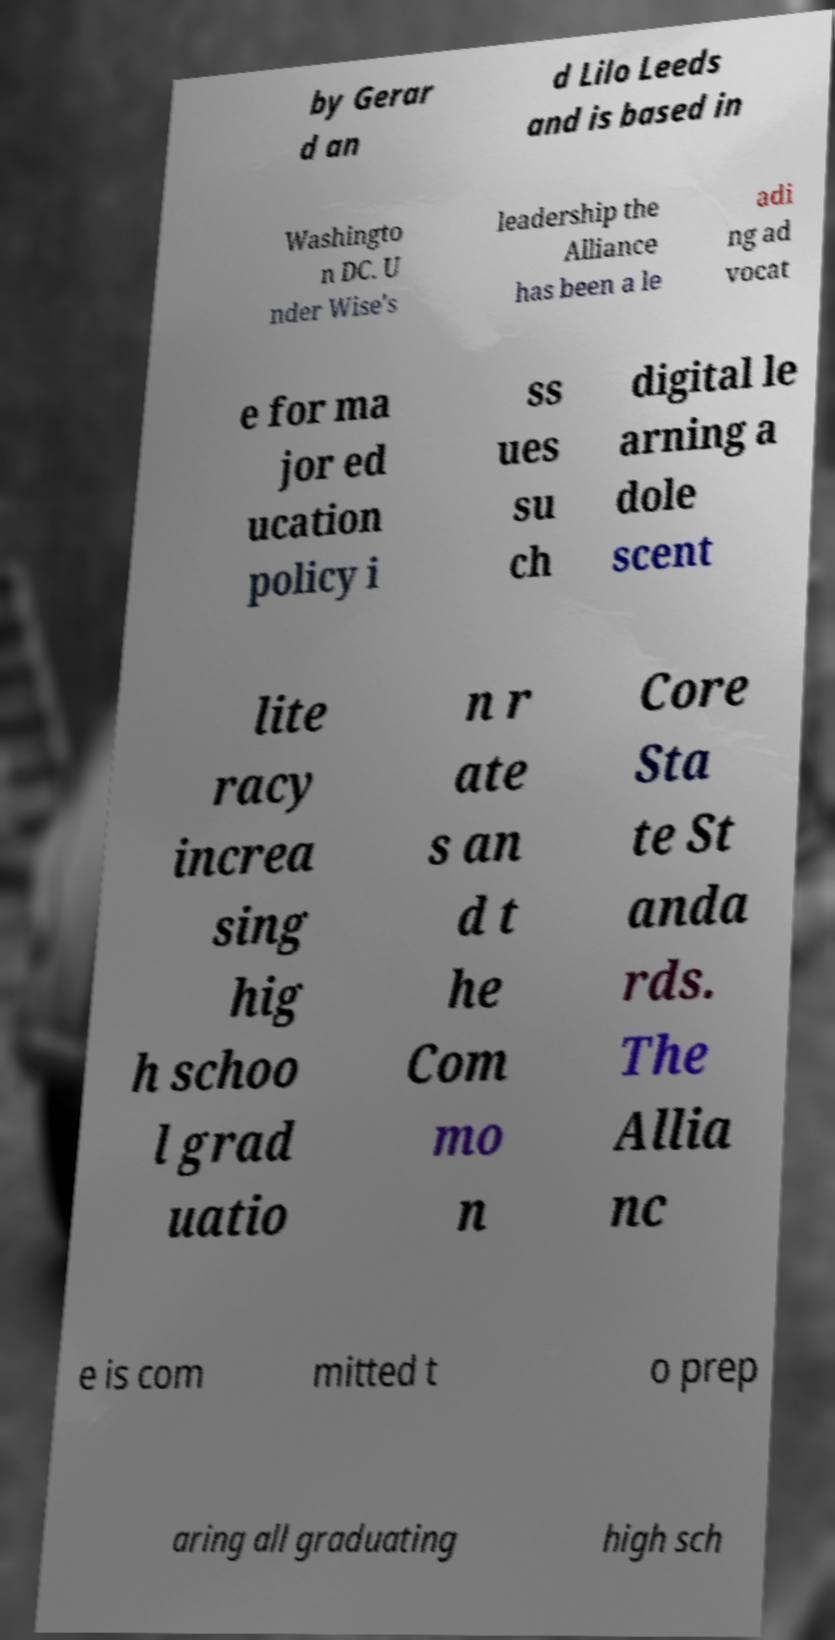Can you accurately transcribe the text from the provided image for me? by Gerar d an d Lilo Leeds and is based in Washingto n DC. U nder Wise's leadership the Alliance has been a le adi ng ad vocat e for ma jor ed ucation policy i ss ues su ch digital le arning a dole scent lite racy increa sing hig h schoo l grad uatio n r ate s an d t he Com mo n Core Sta te St anda rds. The Allia nc e is com mitted t o prep aring all graduating high sch 